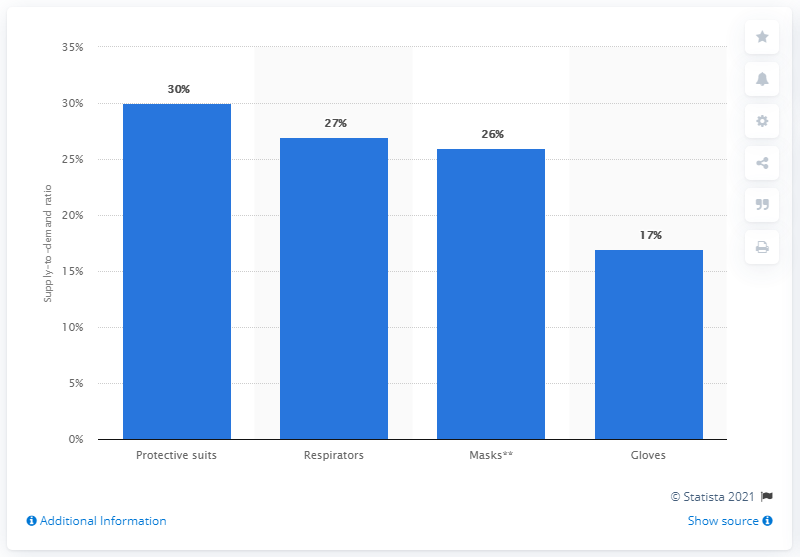Outline some significant characteristics in this image. The availability of gloves for medical personnel who were in direct contact with infected individuals was 17%. 